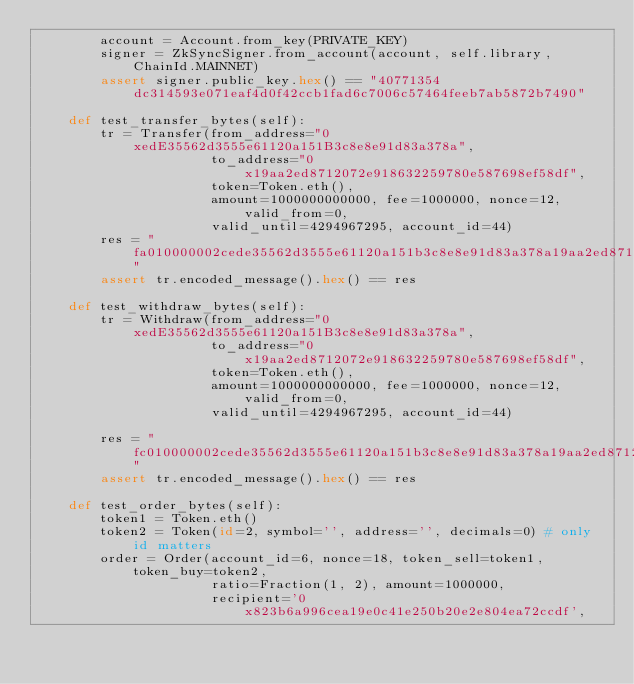<code> <loc_0><loc_0><loc_500><loc_500><_Python_>        account = Account.from_key(PRIVATE_KEY)
        signer = ZkSyncSigner.from_account(account, self.library, ChainId.MAINNET)
        assert signer.public_key.hex() == "40771354dc314593e071eaf4d0f42ccb1fad6c7006c57464feeb7ab5872b7490"

    def test_transfer_bytes(self):
        tr = Transfer(from_address="0xedE35562d3555e61120a151B3c8e8e91d83a378a",
                      to_address="0x19aa2ed8712072e918632259780e587698ef58df",
                      token=Token.eth(),
                      amount=1000000000000, fee=1000000, nonce=12, valid_from=0,
                      valid_until=4294967295, account_id=44)
        res = "fa010000002cede35562d3555e61120a151b3c8e8e91d83a378a19aa2ed8712072e918632259780e587698ef58df000000004a817c80027d030000000c000000000000000000000000ffffffff"
        assert tr.encoded_message().hex() == res

    def test_withdraw_bytes(self):
        tr = Withdraw(from_address="0xedE35562d3555e61120a151B3c8e8e91d83a378a",
                      to_address="0x19aa2ed8712072e918632259780e587698ef58df",
                      token=Token.eth(),
                      amount=1000000000000, fee=1000000, nonce=12, valid_from=0,
                      valid_until=4294967295, account_id=44)

        res = "fc010000002cede35562d3555e61120a151b3c8e8e91d83a378a19aa2ed8712072e918632259780e587698ef58df000000000000000000000000000000e8d4a510007d030000000c000000000000000000000000ffffffff"
        assert tr.encoded_message().hex() == res

    def test_order_bytes(self):
        token1 = Token.eth()
        token2 = Token(id=2, symbol='', address='', decimals=0) # only id matters
        order = Order(account_id=6, nonce=18, token_sell=token1, token_buy=token2,
                      ratio=Fraction(1, 2), amount=1000000,
                      recipient='0x823b6a996cea19e0c41e250b20e2e804ea72ccdf',</code> 